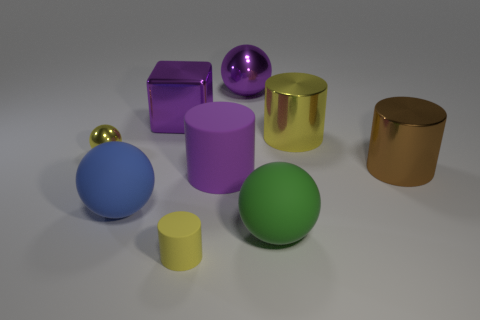Subtract 1 cylinders. How many cylinders are left? 3 Add 1 tiny yellow spheres. How many objects exist? 10 Subtract all spheres. How many objects are left? 5 Add 5 gray metal blocks. How many gray metal blocks exist? 5 Subtract 1 yellow balls. How many objects are left? 8 Subtract all big brown cylinders. Subtract all purple rubber cylinders. How many objects are left? 7 Add 2 yellow rubber cylinders. How many yellow rubber cylinders are left? 3 